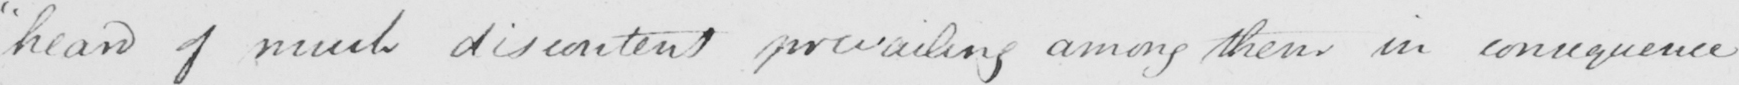Please provide the text content of this handwritten line. " heard of much discontent prevailing among them in consequence 